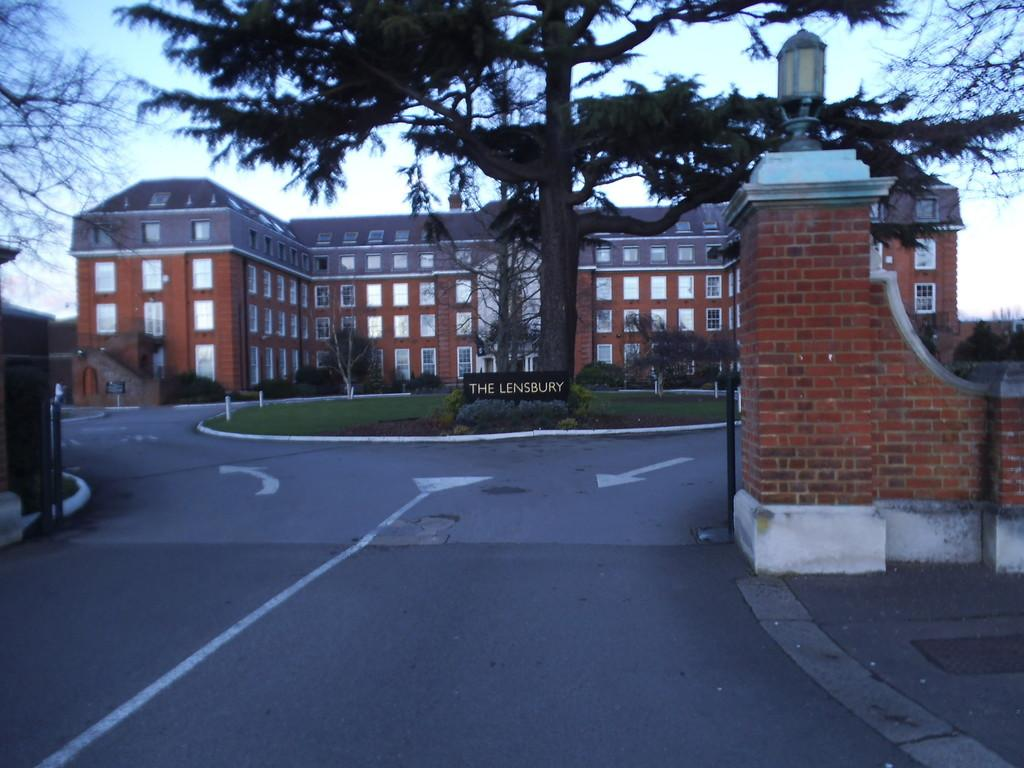What is the color of the house in the image? The house in the image is brown. What type of windows does the house have? The house has glass windows. What is located in front of the house? There is a boundary wall and a huge tree in front of the house. What can be seen at the bottom of the image? There is a road at the front bottom side of the image. How many knots are tied on the tree in the image? There are no knots visible on the tree in the image. What type of alley can be seen behind the house in the image? There is no alley visible behind the house in the image. 